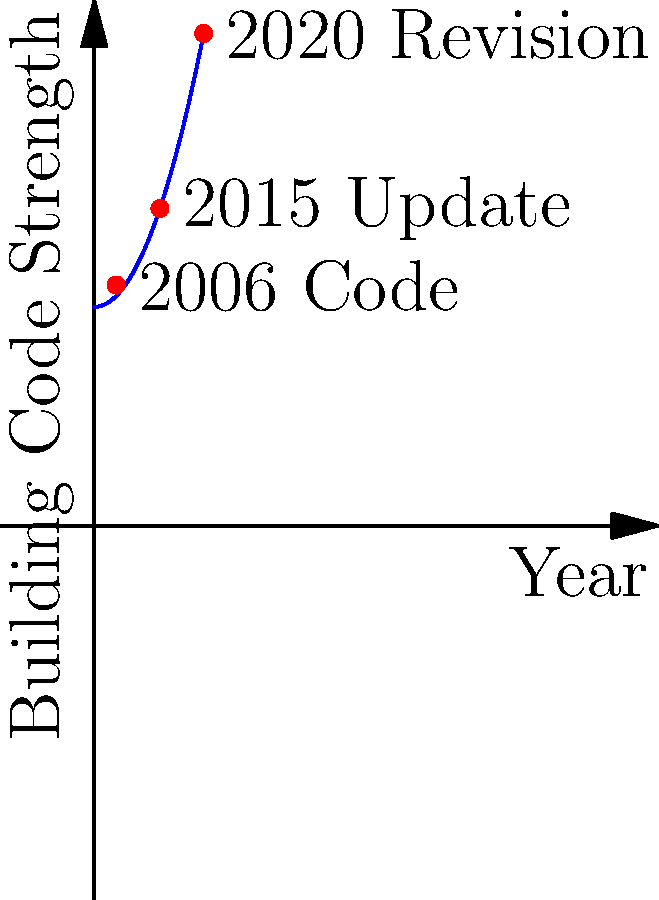Based on the structural diagram representing the development of earthquake-resistant building codes in Bangladesh, which year marked a significant update that substantially increased the code strength, and what factors might have influenced this change? To answer this question, let's analyze the diagram step-by-step:

1. The x-axis represents time (years), while the y-axis represents the strength of building codes.

2. We can see three key points marked on the curve:
   - 2006 Code
   - 2015 Update
   - 2020 Revision

3. The curve shows an increasing trend, indicating that building code strength has been improving over time.

4. Comparing the three points, we can observe that the steepest increase occurs between the 2006 Code and the 2015 Update.

5. This significant jump in code strength from 2006 to 2015 suggests that 2015 marked a substantial update in earthquake-resistant building codes in Bangladesh.

6. Factors that might have influenced this change could include:
   - Increased awareness of seismic risks in Bangladesh
   - Lessons learned from major earthquakes in neighboring countries
   - Advancements in structural engineering and seismology
   - International pressure or cooperation to improve building safety standards
   - Changes in government policies or increased focus on disaster preparedness

7. As an archivist specializing in the legislative history of Bangladesh, you would likely be aware of the specific legislative actions or policy changes that led to this significant update in 2015.
Answer: 2015, due to increased seismic awareness and engineering advancements. 